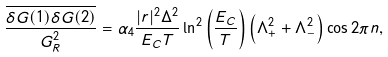Convert formula to latex. <formula><loc_0><loc_0><loc_500><loc_500>\frac { \overline { \delta G ( 1 ) \delta G ( 2 ) } } { G _ { R } ^ { 2 } } = \alpha _ { 4 } \frac { | r | ^ { 2 } \Delta ^ { 2 } } { E _ { C } T } \ln ^ { 2 } \left ( \frac { E _ { C } } { T } \right ) \left ( \Lambda _ { + } ^ { 2 } + \Lambda _ { - } ^ { 2 } \right ) \cos 2 \pi n ,</formula> 